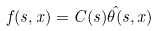<formula> <loc_0><loc_0><loc_500><loc_500>f ( s , x ) = C ( s ) \hat { \theta } ( s , x )</formula> 